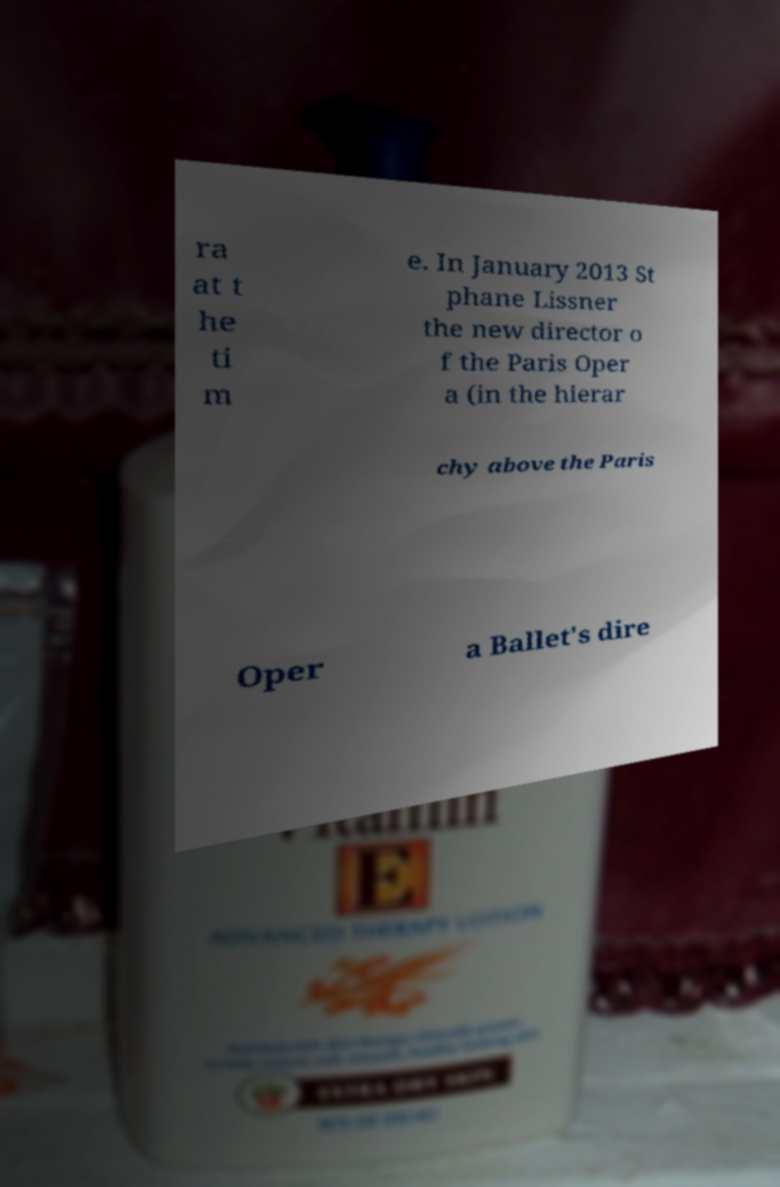Please read and relay the text visible in this image. What does it say? ra at t he ti m e. In January 2013 St phane Lissner the new director o f the Paris Oper a (in the hierar chy above the Paris Oper a Ballet's dire 